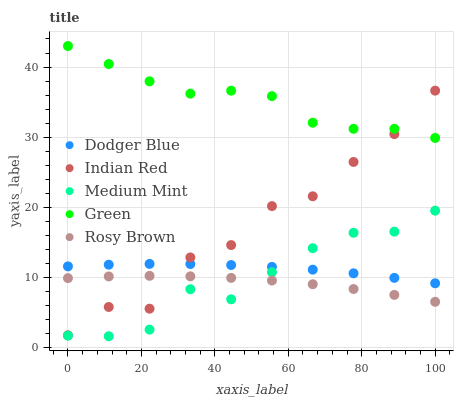Does Rosy Brown have the minimum area under the curve?
Answer yes or no. Yes. Does Green have the maximum area under the curve?
Answer yes or no. Yes. Does Green have the minimum area under the curve?
Answer yes or no. No. Does Rosy Brown have the maximum area under the curve?
Answer yes or no. No. Is Dodger Blue the smoothest?
Answer yes or no. Yes. Is Indian Red the roughest?
Answer yes or no. Yes. Is Green the smoothest?
Answer yes or no. No. Is Green the roughest?
Answer yes or no. No. Does Medium Mint have the lowest value?
Answer yes or no. Yes. Does Rosy Brown have the lowest value?
Answer yes or no. No. Does Green have the highest value?
Answer yes or no. Yes. Does Rosy Brown have the highest value?
Answer yes or no. No. Is Medium Mint less than Green?
Answer yes or no. Yes. Is Green greater than Dodger Blue?
Answer yes or no. Yes. Does Indian Red intersect Dodger Blue?
Answer yes or no. Yes. Is Indian Red less than Dodger Blue?
Answer yes or no. No. Is Indian Red greater than Dodger Blue?
Answer yes or no. No. Does Medium Mint intersect Green?
Answer yes or no. No. 